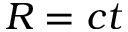<formula> <loc_0><loc_0><loc_500><loc_500>R = c t</formula> 